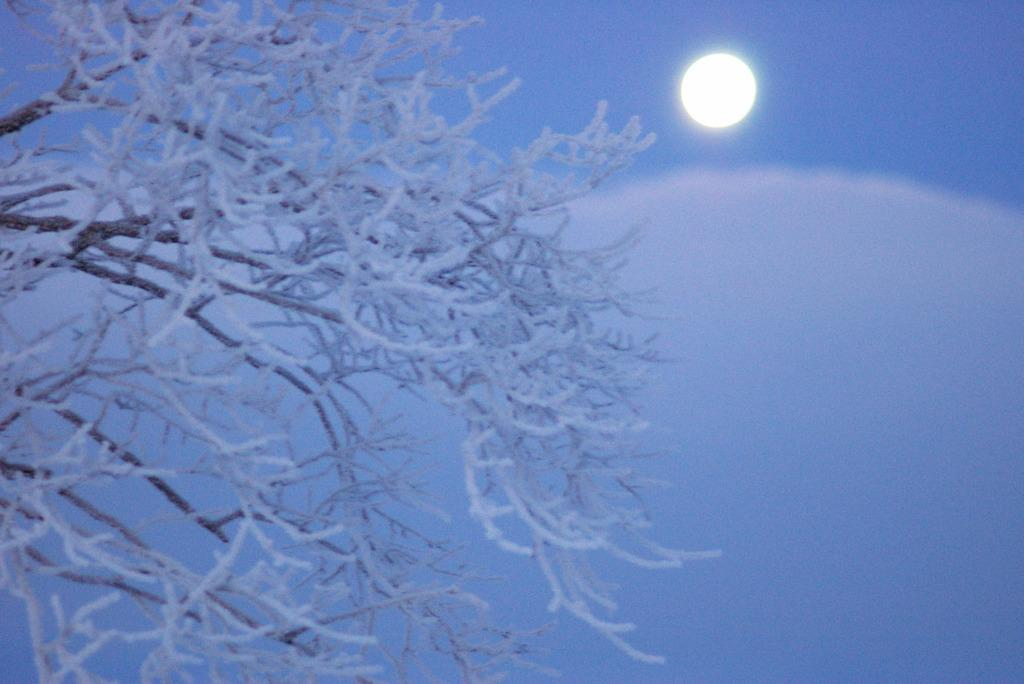What is the main subject of the image? There is a tree in the image. What is the condition of the tree in the image? The tree is covered with snow. What can be seen in the sky in the background of the image? There is a moon visible in the sky in the background of the image. What type of behavior is the plate exhibiting in the image? There is no plate present in the image, so it cannot exhibit any behavior. 